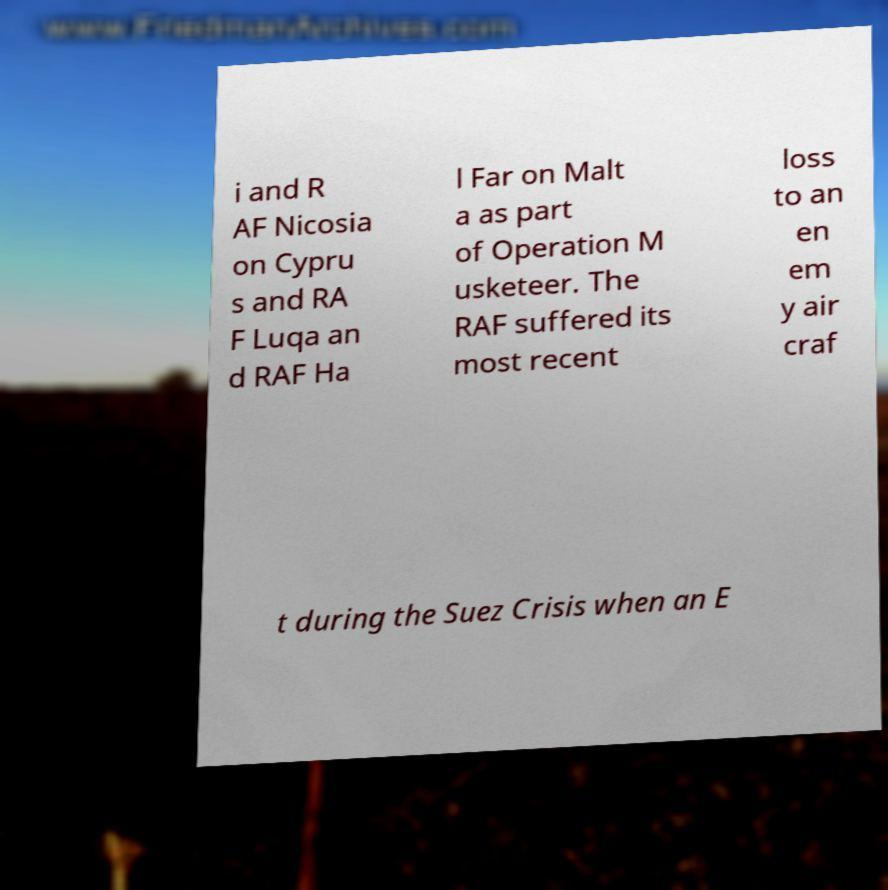There's text embedded in this image that I need extracted. Can you transcribe it verbatim? i and R AF Nicosia on Cypru s and RA F Luqa an d RAF Ha l Far on Malt a as part of Operation M usketeer. The RAF suffered its most recent loss to an en em y air craf t during the Suez Crisis when an E 